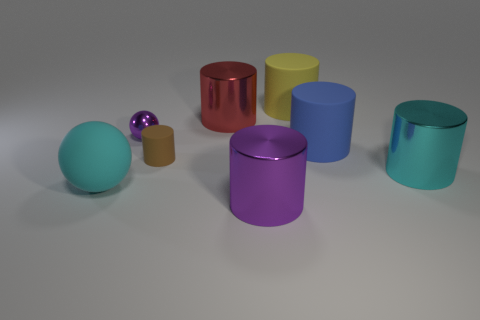Add 1 red shiny things. How many objects exist? 9 Subtract all big cyan cylinders. How many cylinders are left? 5 Subtract all balls. How many objects are left? 6 Subtract all cyan balls. How many balls are left? 1 Subtract 1 spheres. How many spheres are left? 1 Subtract all yellow rubber things. Subtract all small yellow metallic balls. How many objects are left? 7 Add 7 big blue cylinders. How many big blue cylinders are left? 8 Add 6 large gray cubes. How many large gray cubes exist? 6 Subtract 1 purple spheres. How many objects are left? 7 Subtract all yellow balls. Subtract all cyan blocks. How many balls are left? 2 